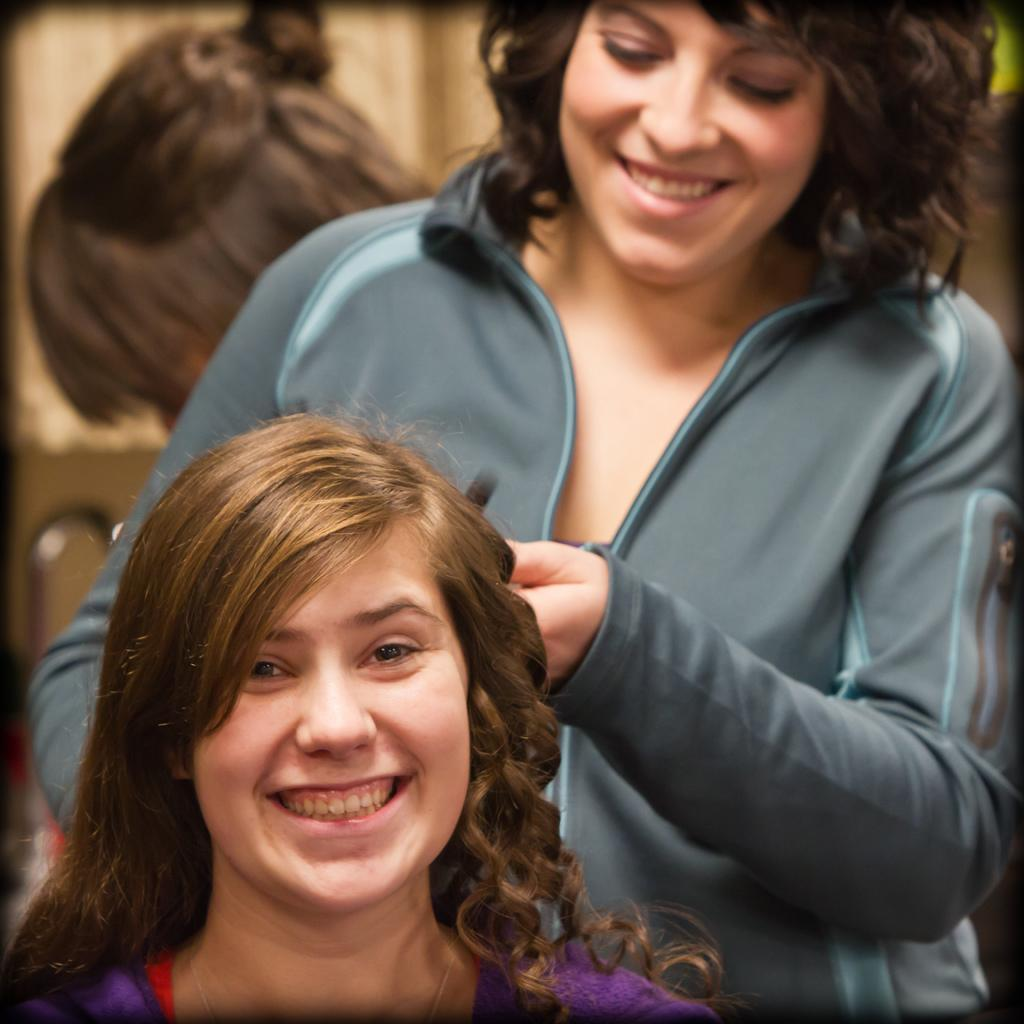What is the position of the woman in the image? There is a woman sitting in the image. Can you describe the other woman in the image? There is another woman standing in the image. What is the standing woman doing? The standing woman is curling her hair. What type of brass instrument is the woman playing in the image? There is no brass instrument present in the image; the standing woman is curling her hair. 